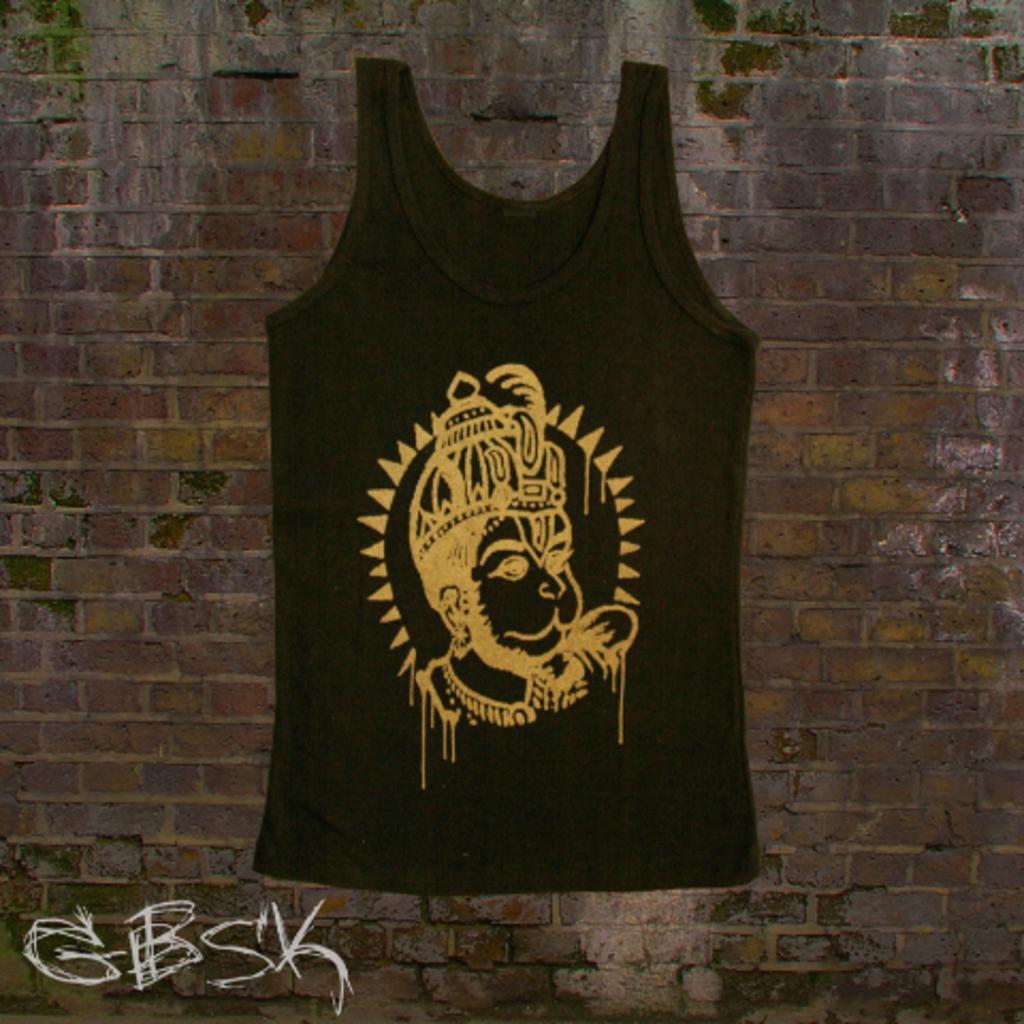Describe this image in one or two sentences. In this picture we can see a printed vest on the wall. In the bottom left corner of the picture we can see letters. 